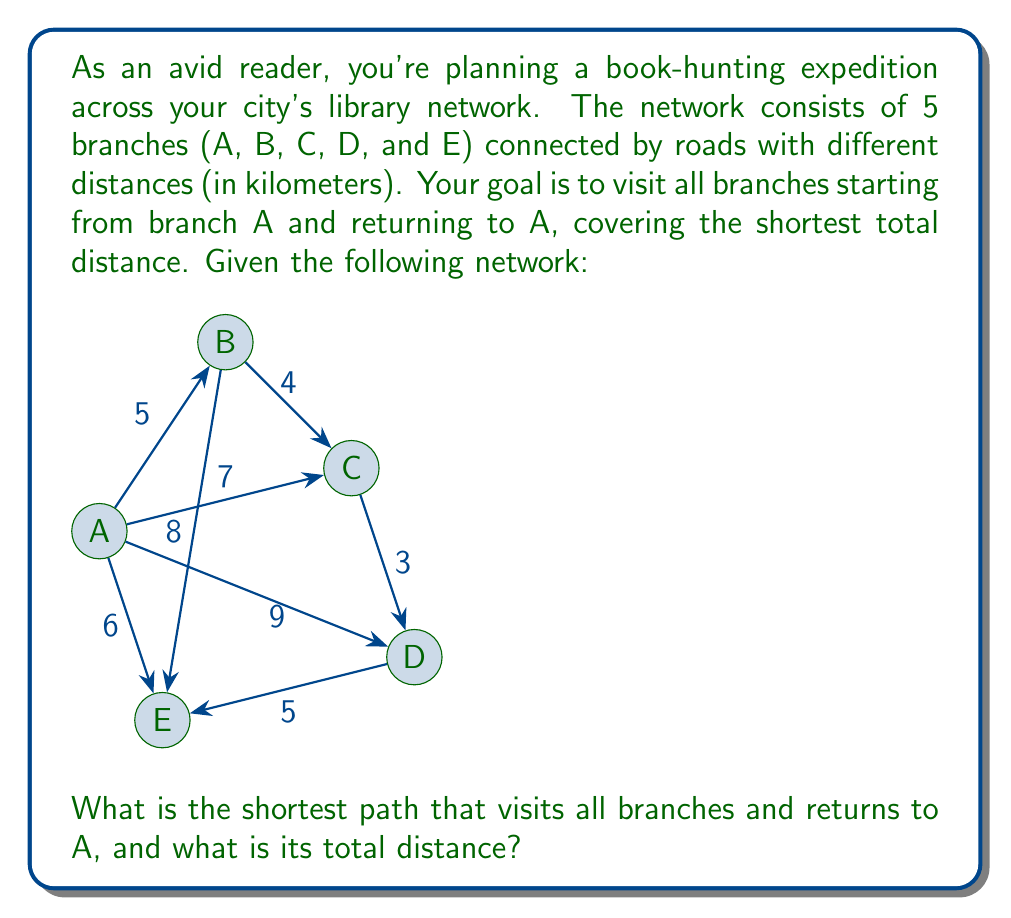Help me with this question. To solve this problem, we can use the concept of the Traveling Salesman Problem (TSP) from graph theory. Since the number of nodes is small, we can use a brute-force approach to find the optimal solution.

Steps:
1) List all possible permutations of the branches B, C, D, and E.
2) For each permutation, calculate the total distance of the path starting and ending at A.
3) Choose the permutation with the shortest total distance.

Possible permutations:
1. BCDE
2. BCED
3. BDCE
4. BDEC
5. BECD
6. BEDC
7. CBDE
8. CBED
9. CDBE
10. CDEB
11. CEBD
12. CEDB
13. DBCE
14. DBEC
15. DCBE
16. DCEB
17. DEBC
18. DECB
19. EBCD
20. EBDC
21. ECBD
22. ECDB
23. EDBC
24. EDCB

Let's calculate the distance for each permutation:

1. ABCDEA: 5 + 4 + 3 + 5 + 6 = 23
2. ABCEDA: 5 + 4 + 3 + 5 + 9 = 26
3. ABDCEA: 5 + 8 + 5 + 3 + 7 = 28
4. ABDECA: 5 + 8 + 5 + 6 + 7 = 31
5. ABECDA: 5 + 8 + 6 + 5 + 9 = 33
6. ABEDCA: 5 + 8 + 6 + 5 + 7 = 31
7. ACBDEA: 7 + 4 + 8 + 5 + 6 = 30
8. ACBEDA: 7 + 4 + 8 + 6 + 9 = 34
9. ACDBEA: 7 + 3 + 5 + 8 + 6 = 29
10. ACDEBA: 7 + 3 + 5 + 6 + 9 = 30
11.ACEBDA: 7 + 4 + 8 + 5 + 9 = 33
12. ACEDBA: 7 + 4 + 8 + 5 + 9 = 33
13. ADBCEA: 9 + 5 + 8 + 4 + 7 = 33
14. ADBECA: 9 + 5 + 8 + 6 + 7 = 35
15. ADCBEA: 9 + 3 + 4 + 8 + 6 = 30
16. ADCEBA: 9 + 3 + 4 + 6 + 9 = 31
17. ADEBCA: 9 + 5 + 6 + 8 + 7 = 35
18. ADECBA: 9 + 5 + 6 + 4 + 7 = 31
19. AEBCDA: 6 + 8 + 4 + 3 + 9 = 30
20. AEBDCA: 6 + 8 + 5 + 3 + 7 = 29
21. AECBDA: 6 + 8 + 4 + 5 + 9 = 32
22. AECDBA: 6 + 8 + 4 + 3 + 9 = 30
23. AEDBCA: 6 + 5 + 3 + 4 + 7 = 25
24. AEDCBA: 6 + 5 + 3 + 4 + 7 = 25

The shortest paths are AEDBCA and AEDCBA, both with a total distance of 25 km.
Answer: The shortest path is either A-E-D-B-C-A or A-E-D-C-B-A, with a total distance of 25 km. 